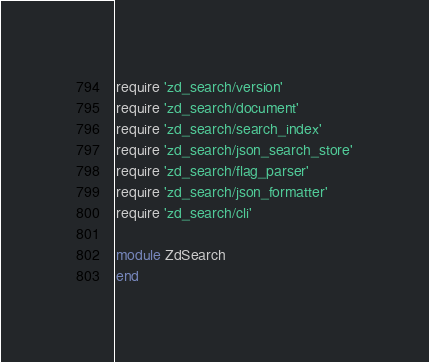<code> <loc_0><loc_0><loc_500><loc_500><_Ruby_>require 'zd_search/version'
require 'zd_search/document'
require 'zd_search/search_index'
require 'zd_search/json_search_store'
require 'zd_search/flag_parser'
require 'zd_search/json_formatter'
require 'zd_search/cli'

module ZdSearch
end
</code> 